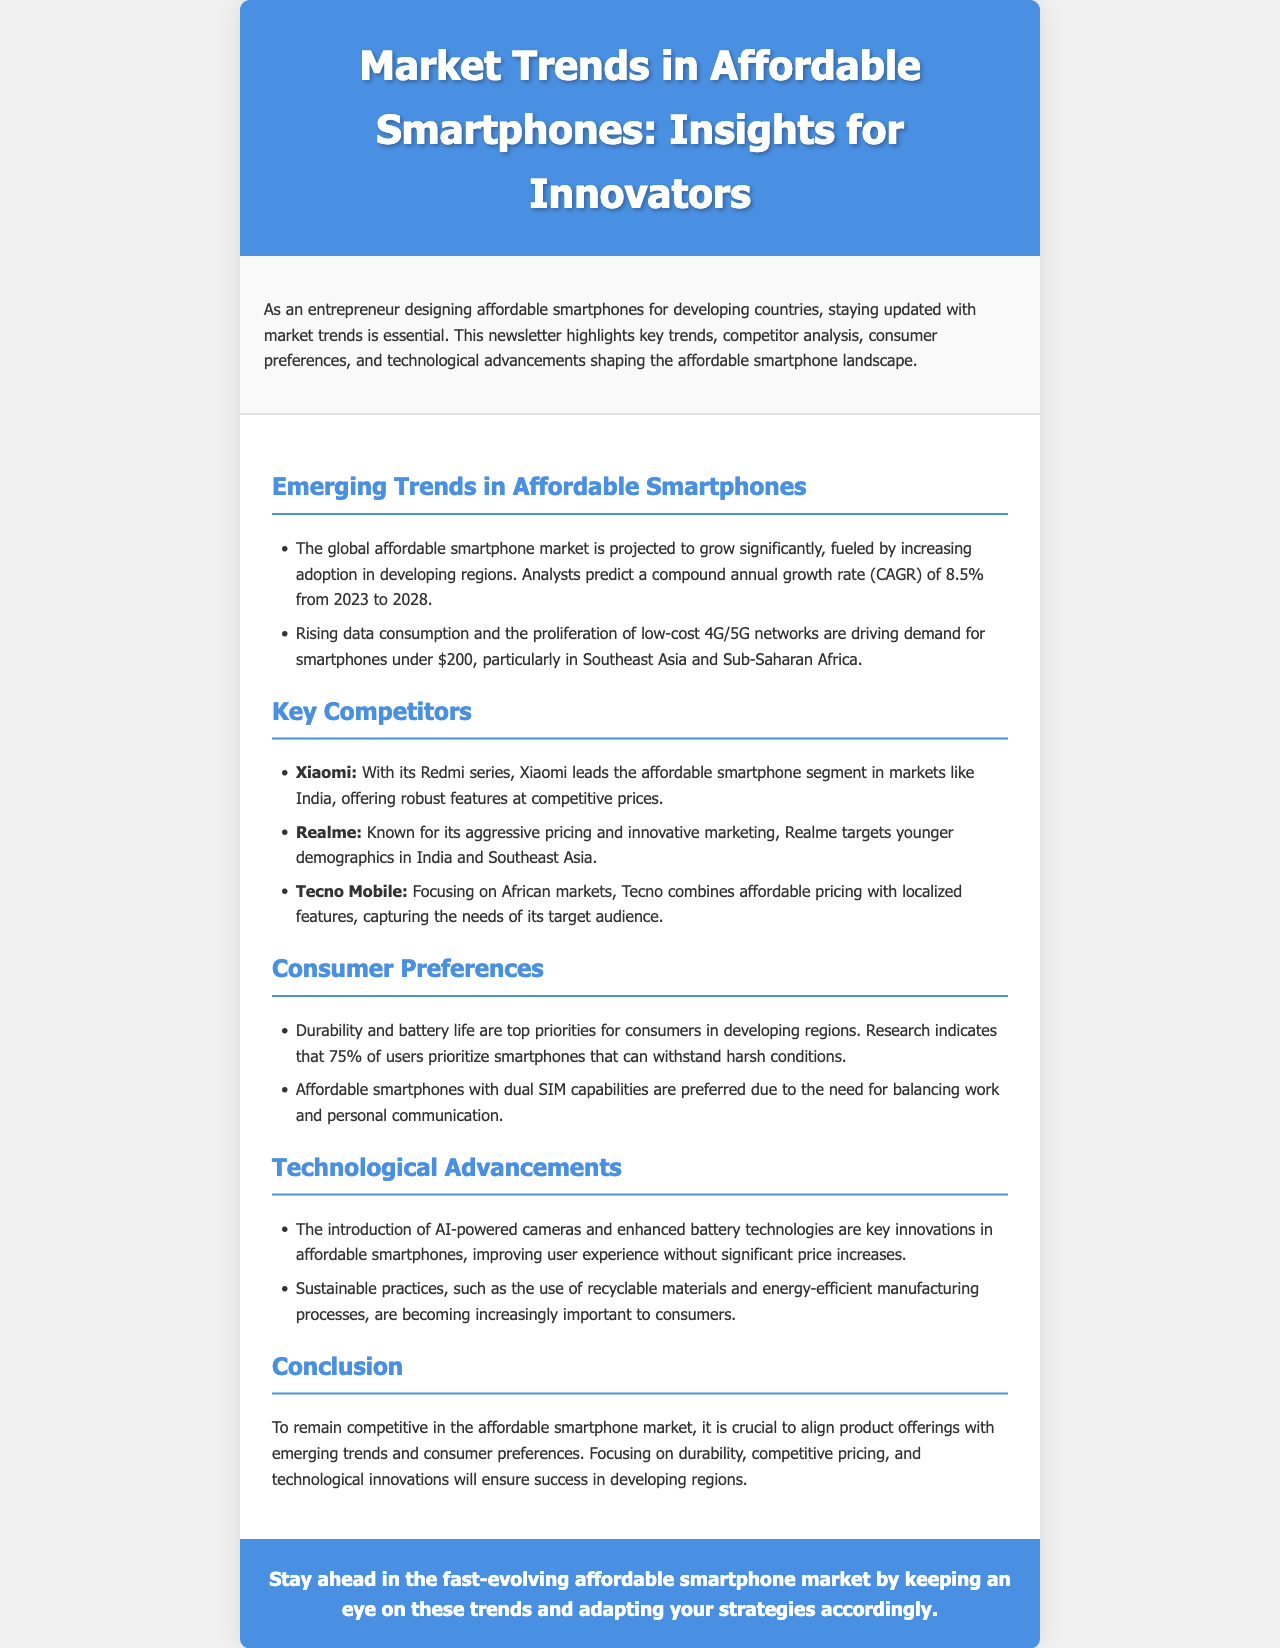What is the projected CAGR for the affordable smartphone market from 2023 to 2028? The document states a compound annual growth rate (CAGR) of 8.5% from 2023 to 2028.
Answer: 8.5% Which company leads the affordable smartphone segment in India? According to the document, Xiaomi leads the segment in India with its Redmi series.
Answer: Xiaomi What are the top priorities for consumers in developing regions? The document mentions that durability and battery life are top priorities for consumers.
Answer: Durability and battery life What is a significant factor driving demand for smartphones under $200? The rise of low-cost 4G/5G networks is driving demand for these smartphones as noted in the document.
Answer: Low-cost 4G/5G networks Which technological advancement is mentioned as improving user experience? The introduction of AI-powered cameras is highlighted as a key innovation improving user experience.
Answer: AI-powered cameras How much of the user base prioritizes smartphones that can withstand harsh conditions? The document states that 75% of users prioritize these smartphones.
Answer: 75% What is a competitive aspect of Tecno Mobile? Tecno Mobile is noted for combining affordable pricing with localized features in the document.
Answer: Localized features What is an important sustainable practice mentioned in the document? The document mentions the use of recyclable materials as an important sustainable practice.
Answer: Recyclable materials 